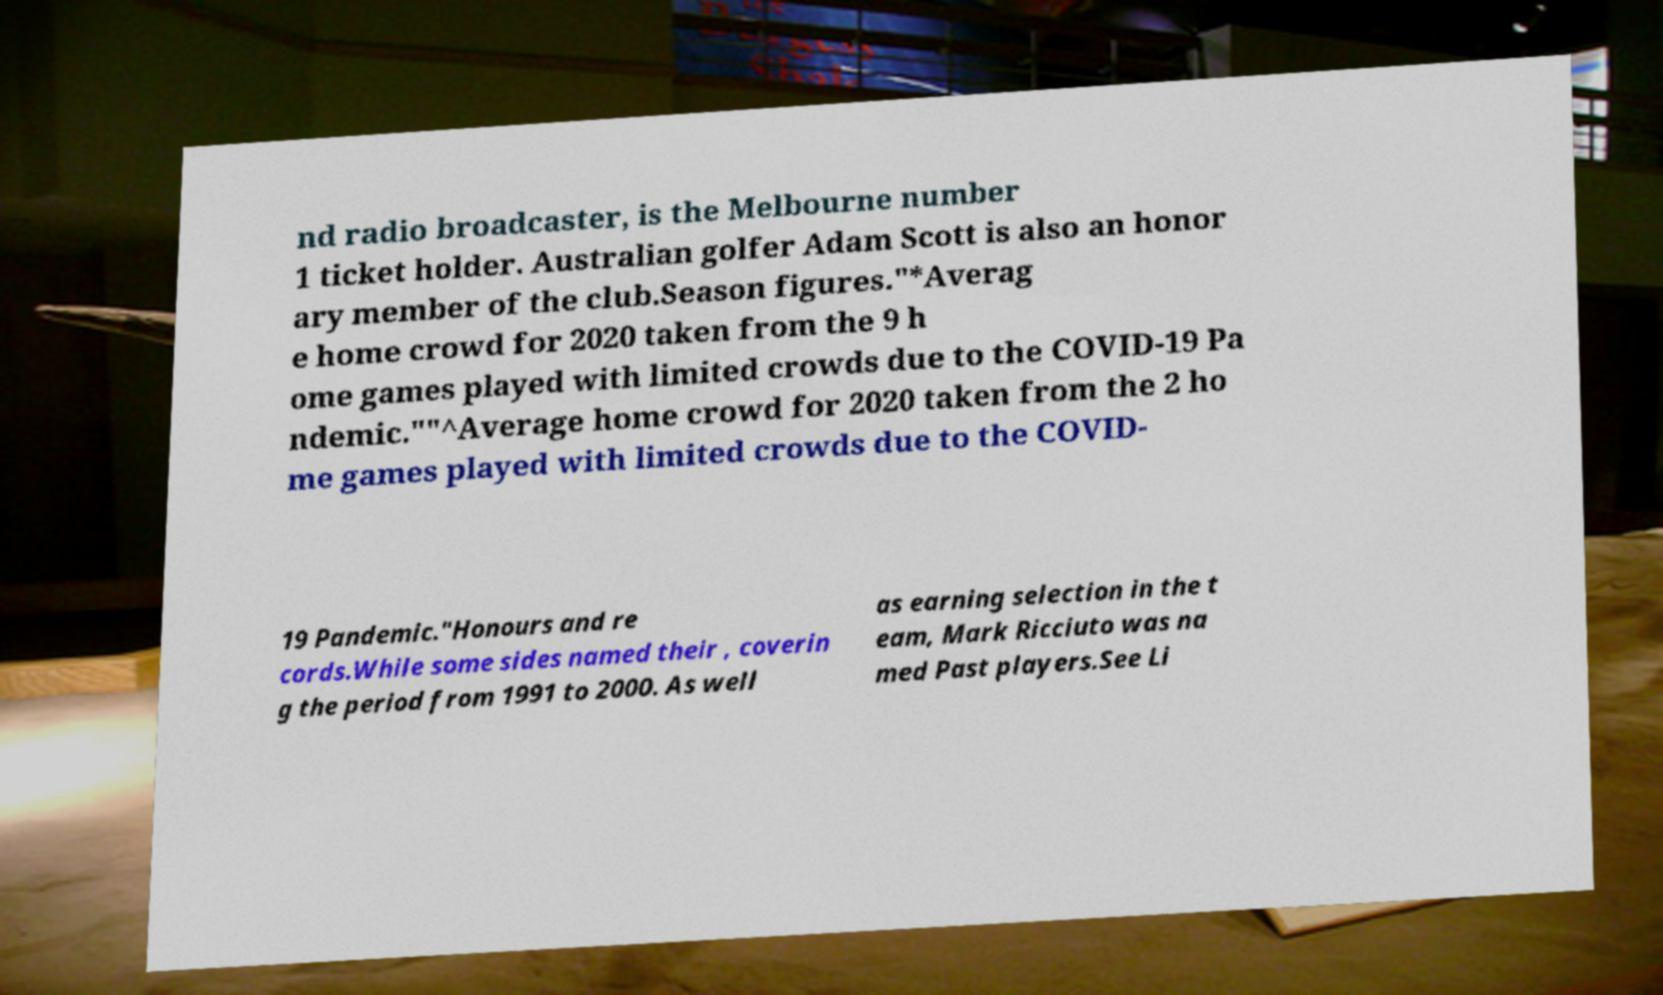For documentation purposes, I need the text within this image transcribed. Could you provide that? nd radio broadcaster, is the Melbourne number 1 ticket holder. Australian golfer Adam Scott is also an honor ary member of the club.Season figures."*Averag e home crowd for 2020 taken from the 9 h ome games played with limited crowds due to the COVID-19 Pa ndemic.""^Average home crowd for 2020 taken from the 2 ho me games played with limited crowds due to the COVID- 19 Pandemic."Honours and re cords.While some sides named their , coverin g the period from 1991 to 2000. As well as earning selection in the t eam, Mark Ricciuto was na med Past players.See Li 